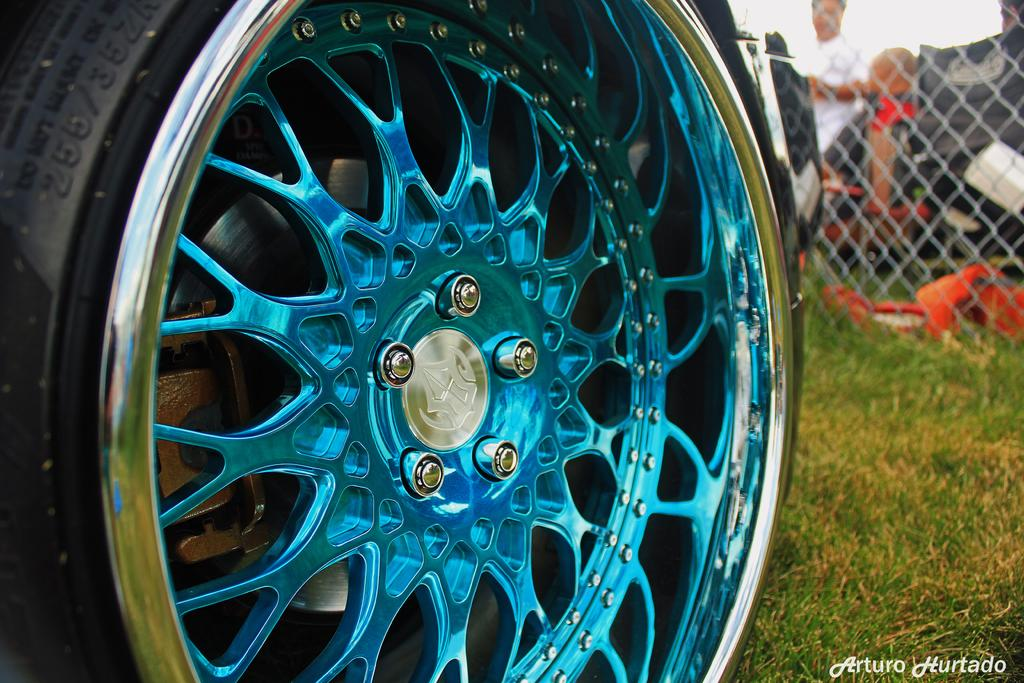What is located in the foreground of the picture? There is a tyre in the foreground of the picture. What type of vegetation can be seen on the right side of the image? There is grass on the right side of the image. How would you describe the background of the image? The background of the image is blurred. Can you identify any human presence in the image? Yes, there are people in the background of the image. What architectural feature is visible in the background? There is fencing in the background of the image. How many clocks are visible in the image? There are no clocks visible in the image. What type of shoe is being worn by the person in the image? There are no people wearing shoes in the image, as it only shows a tyre in the foreground and a blurred background. 